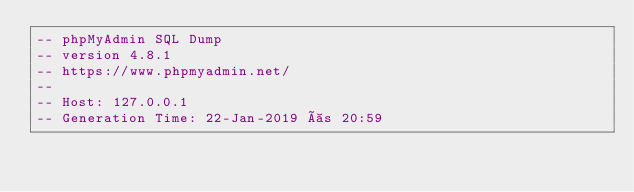<code> <loc_0><loc_0><loc_500><loc_500><_SQL_>-- phpMyAdmin SQL Dump
-- version 4.8.1
-- https://www.phpmyadmin.net/
--
-- Host: 127.0.0.1
-- Generation Time: 22-Jan-2019 às 20:59</code> 